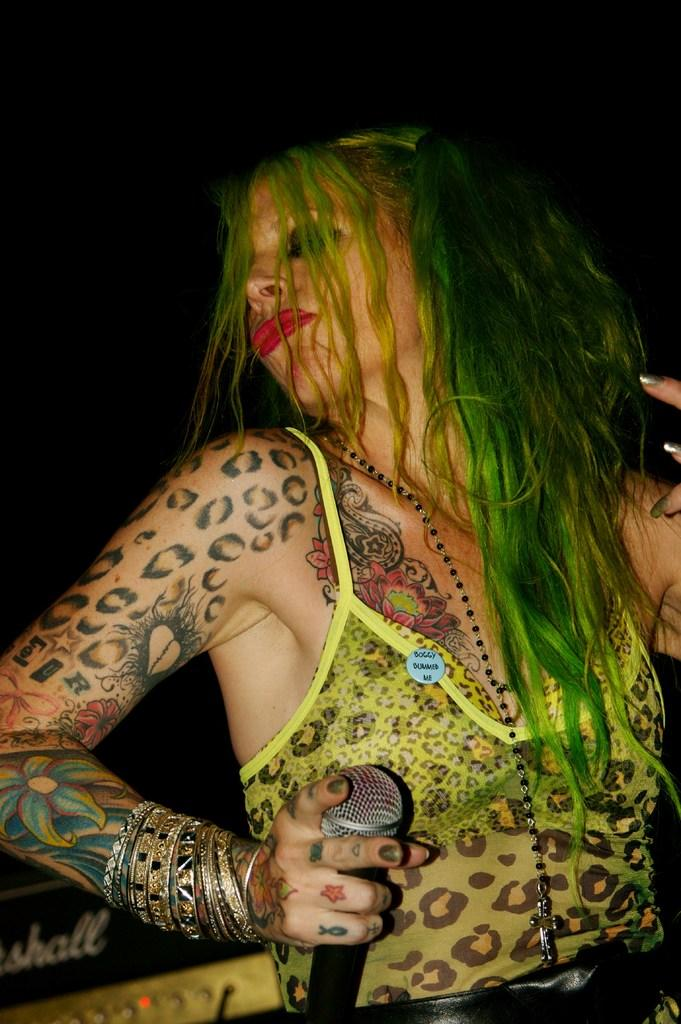What is the main subject of the image? The main subject of the image is a dog playing with a ball in the grass. What is the dog doing in the image? The dog is playing with a ball in the grass. What type of surface is the dog playing on? The dog is playing on grass. How many chickens are there in the image? There are no chickens present in the image; it features a dog playing with a ball in the grass. What type of trees can be seen in the image? There is no mention of trees in the image; it only features a dog playing with a ball in the grass. 